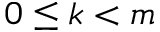Convert formula to latex. <formula><loc_0><loc_0><loc_500><loc_500>0 \leq k < m</formula> 